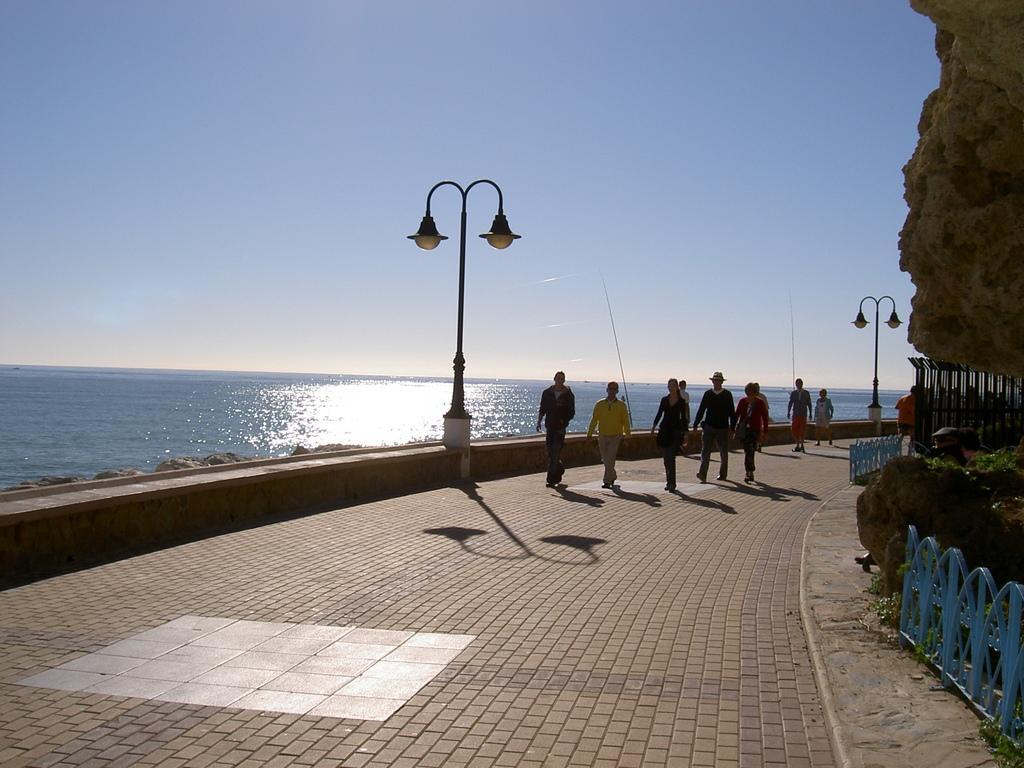In one or two sentences, can you explain what this image depicts? This picture shows few people walking and we see a man wore a hat on his head and we see couple of pole lights and water and we see a blue cloudy sky and a rock on the side and we see metal fence and plants. 